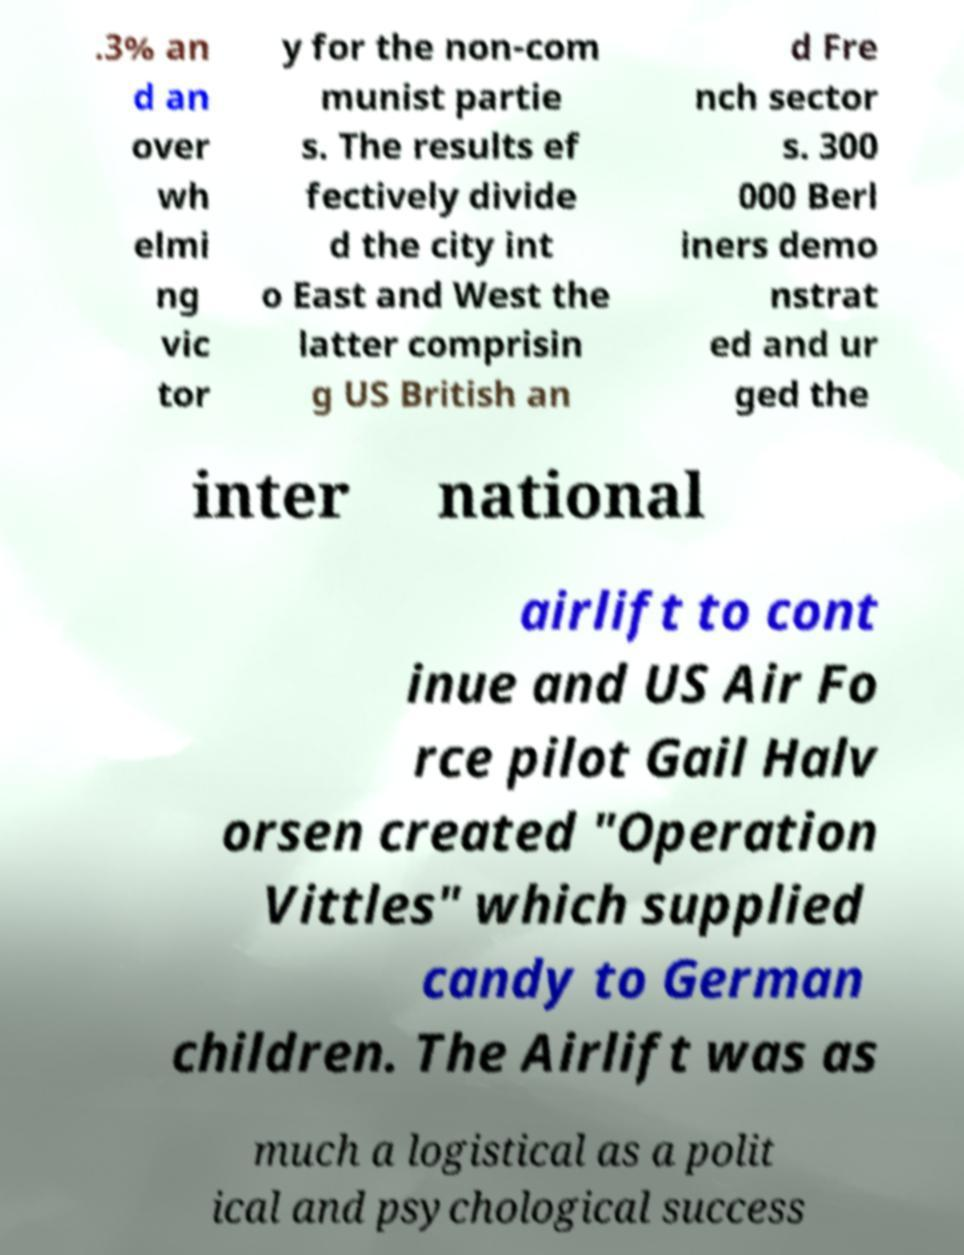There's text embedded in this image that I need extracted. Can you transcribe it verbatim? .3% an d an over wh elmi ng vic tor y for the non-com munist partie s. The results ef fectively divide d the city int o East and West the latter comprisin g US British an d Fre nch sector s. 300 000 Berl iners demo nstrat ed and ur ged the inter national airlift to cont inue and US Air Fo rce pilot Gail Halv orsen created "Operation Vittles" which supplied candy to German children. The Airlift was as much a logistical as a polit ical and psychological success 